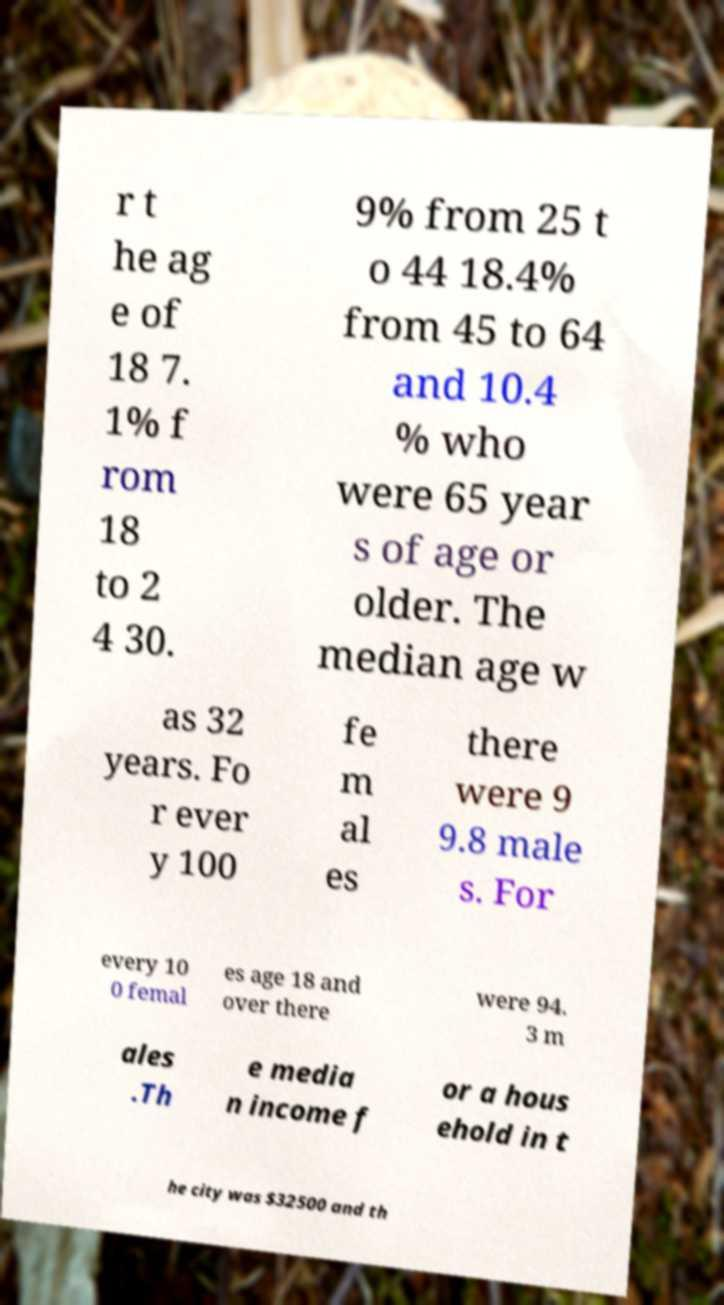Could you extract and type out the text from this image? r t he ag e of 18 7. 1% f rom 18 to 2 4 30. 9% from 25 t o 44 18.4% from 45 to 64 and 10.4 % who were 65 year s of age or older. The median age w as 32 years. Fo r ever y 100 fe m al es there were 9 9.8 male s. For every 10 0 femal es age 18 and over there were 94. 3 m ales .Th e media n income f or a hous ehold in t he city was $32500 and th 